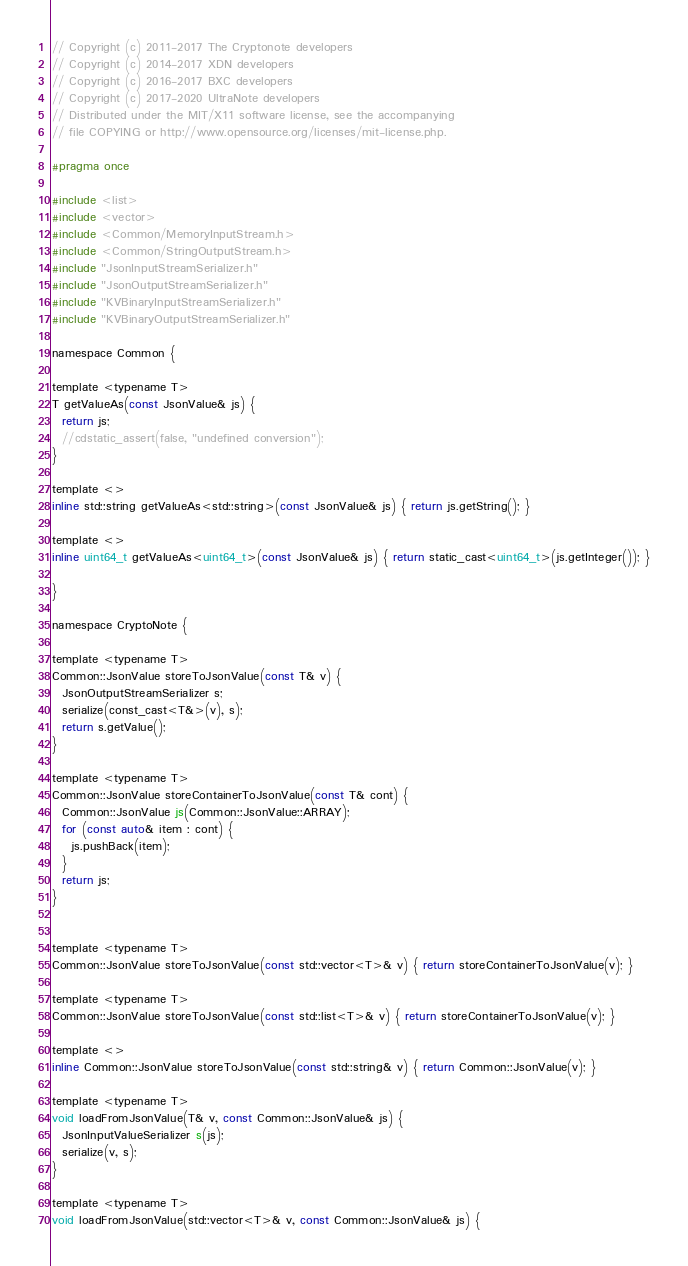<code> <loc_0><loc_0><loc_500><loc_500><_C_>// Copyright (c) 2011-2017 The Cryptonote developers
// Copyright (c) 2014-2017 XDN developers
// Copyright (c) 2016-2017 BXC developers
// Copyright (c) 2017-2020 UltraNote developers
// Distributed under the MIT/X11 software license, see the accompanying
// file COPYING or http://www.opensource.org/licenses/mit-license.php.

#pragma once

#include <list>
#include <vector>
#include <Common/MemoryInputStream.h>
#include <Common/StringOutputStream.h>
#include "JsonInputStreamSerializer.h"
#include "JsonOutputStreamSerializer.h"
#include "KVBinaryInputStreamSerializer.h"
#include "KVBinaryOutputStreamSerializer.h"

namespace Common {

template <typename T>
T getValueAs(const JsonValue& js) {
  return js;
  //cdstatic_assert(false, "undefined conversion");
}

template <>
inline std::string getValueAs<std::string>(const JsonValue& js) { return js.getString(); }

template <>
inline uint64_t getValueAs<uint64_t>(const JsonValue& js) { return static_cast<uint64_t>(js.getInteger()); }

}

namespace CryptoNote {

template <typename T>
Common::JsonValue storeToJsonValue(const T& v) {
  JsonOutputStreamSerializer s;
  serialize(const_cast<T&>(v), s);
  return s.getValue();
}

template <typename T>
Common::JsonValue storeContainerToJsonValue(const T& cont) {
  Common::JsonValue js(Common::JsonValue::ARRAY);
  for (const auto& item : cont) {
    js.pushBack(item);
  }
  return js;
}


template <typename T>
Common::JsonValue storeToJsonValue(const std::vector<T>& v) { return storeContainerToJsonValue(v); }

template <typename T>
Common::JsonValue storeToJsonValue(const std::list<T>& v) { return storeContainerToJsonValue(v); }

template <>
inline Common::JsonValue storeToJsonValue(const std::string& v) { return Common::JsonValue(v); }

template <typename T>
void loadFromJsonValue(T& v, const Common::JsonValue& js) {
  JsonInputValueSerializer s(js);
  serialize(v, s);
}

template <typename T>
void loadFromJsonValue(std::vector<T>& v, const Common::JsonValue& js) {</code> 